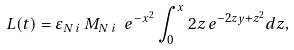<formula> <loc_0><loc_0><loc_500><loc_500>L ( t ) = \varepsilon _ { N \, i } \, M _ { N \, i } \ e ^ { - x ^ { 2 } } \int _ { 0 } ^ { x } 2 z \, e ^ { - 2 z y + z ^ { 2 } } d z ,</formula> 